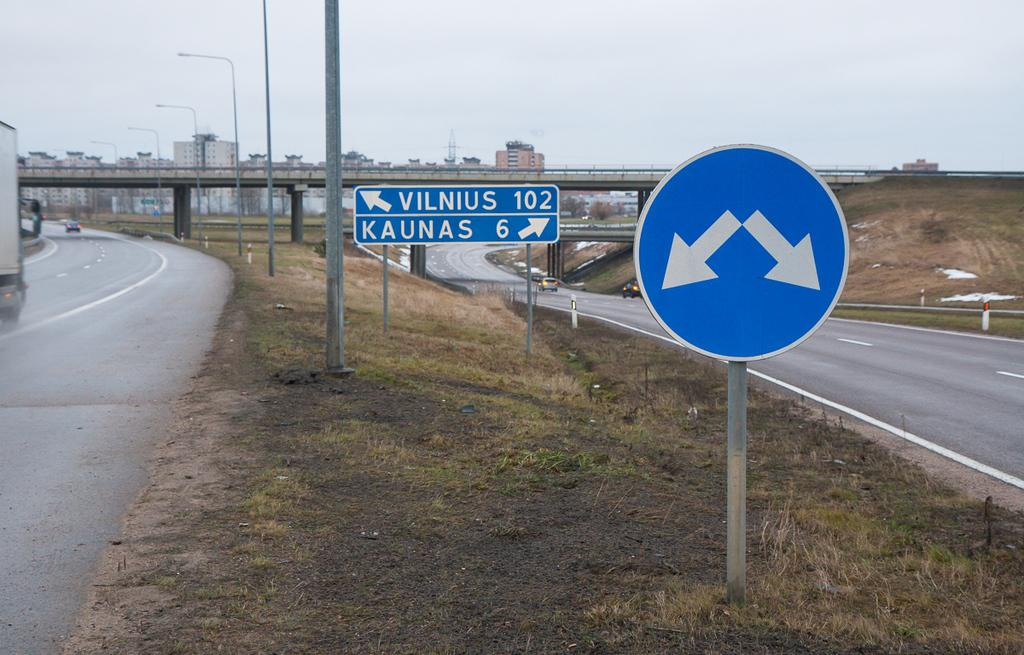<image>
Offer a succinct explanation of the picture presented. Two white and blue signs next to a highway one reads arrows toward vilnius and kaunas. 